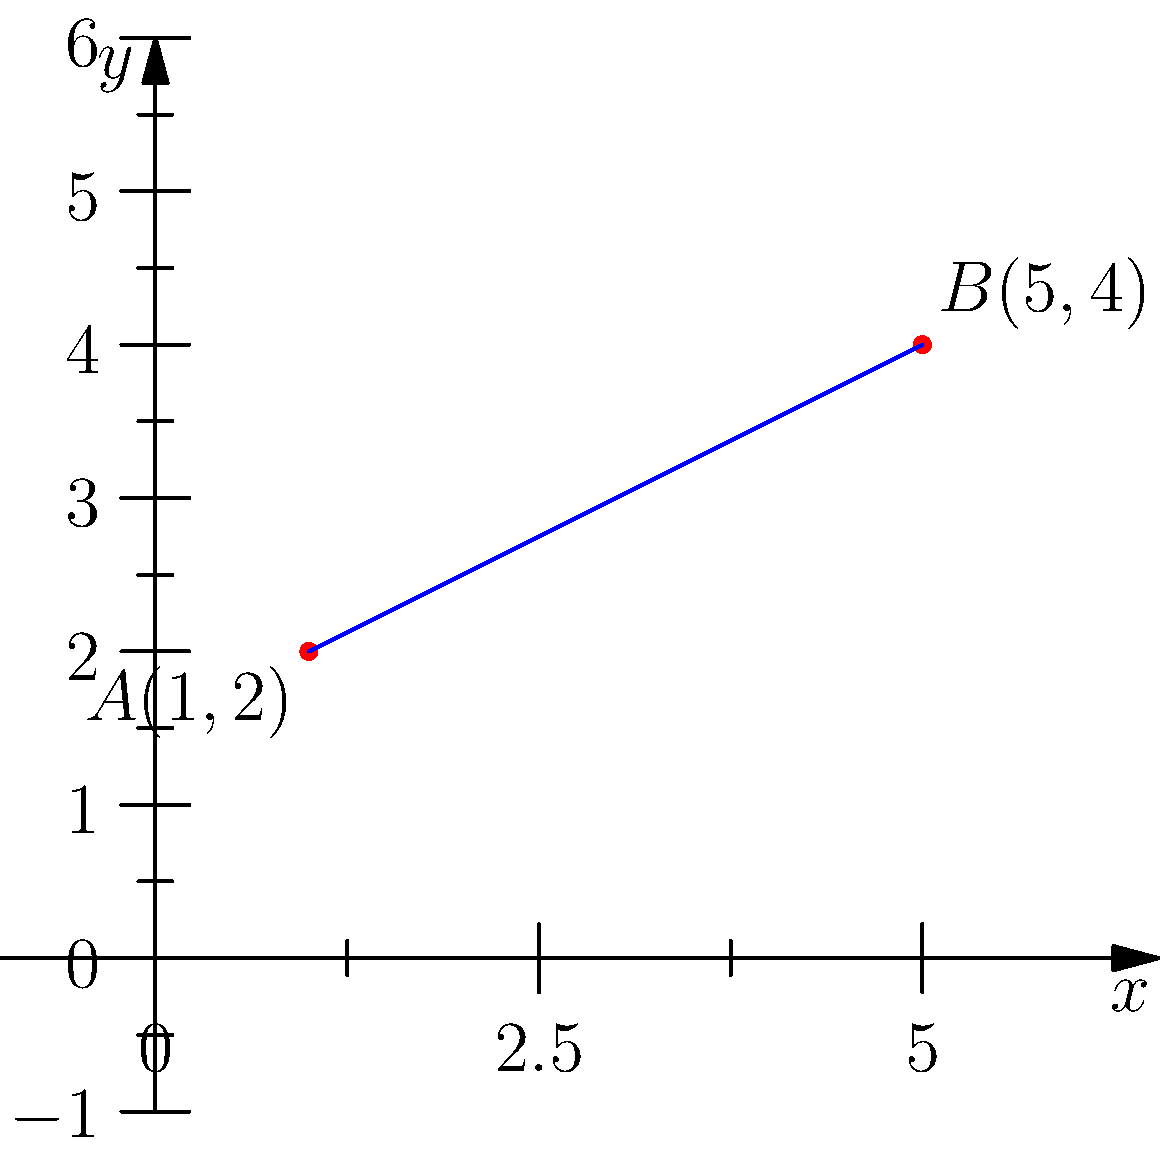As a stay-at-home parent starting a home-based business, you're tracking the growth of your social media followers. You plot two data points on a graph: $A(1,2)$ represents your followers after 1 month, and $B(5,4)$ represents your followers after 5 months. Calculate the slope of the line passing through these two points to determine your average monthly follower growth rate. To find the slope of a line passing through two points, we use the slope formula:

$$ m = \frac{y_2 - y_1}{x_2 - x_1} $$

Where $(x_1, y_1)$ is the first point and $(x_2, y_2)$ is the second point.

Given:
Point A: $(x_1, y_1) = (1, 2)$
Point B: $(x_2, y_2) = (5, 4)$

Step 1: Substitute the values into the slope formula:
$$ m = \frac{4 - 2}{5 - 1} $$

Step 2: Simplify the numerator and denominator:
$$ m = \frac{2}{4} $$

Step 3: Reduce the fraction:
$$ m = \frac{1}{2} = 0.5 $$

The slope of 0.5 represents the average increase in followers per month. This means your social media following is growing by 0.5 followers per month on average.
Answer: $\frac{1}{2}$ or $0.5$ 